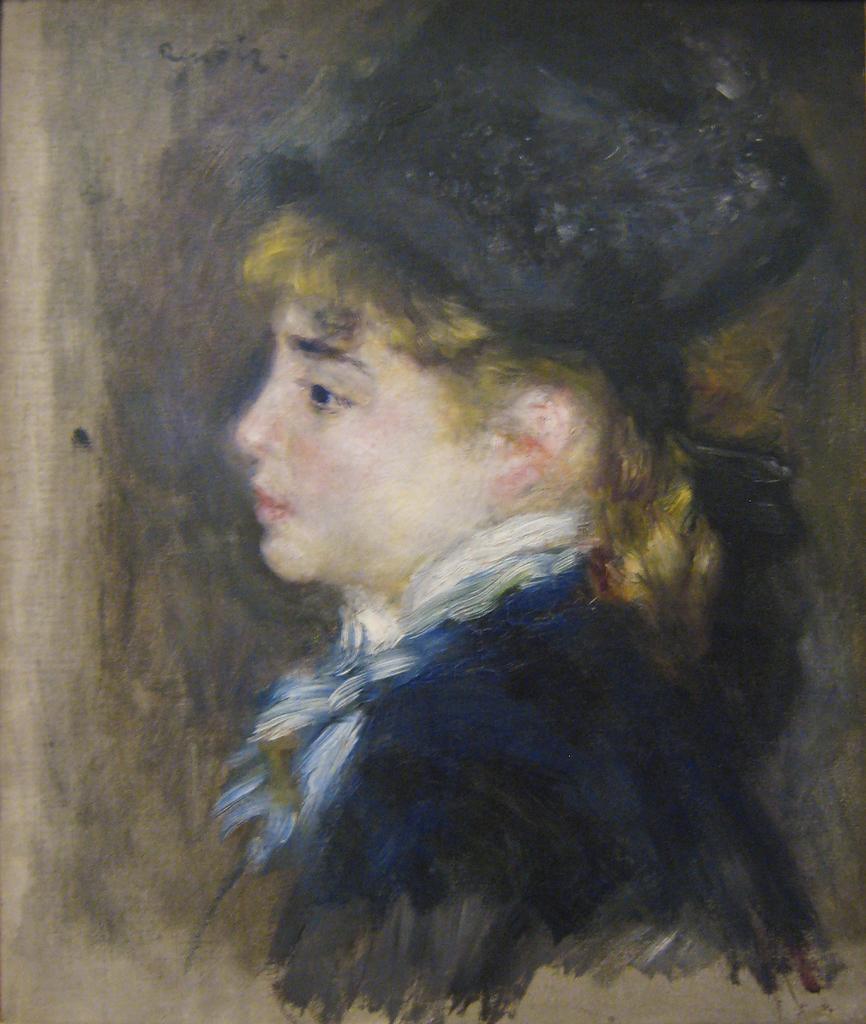Please provide a concise description of this image. In this image we can see a painting of a person on an object looks like a wooden board. 